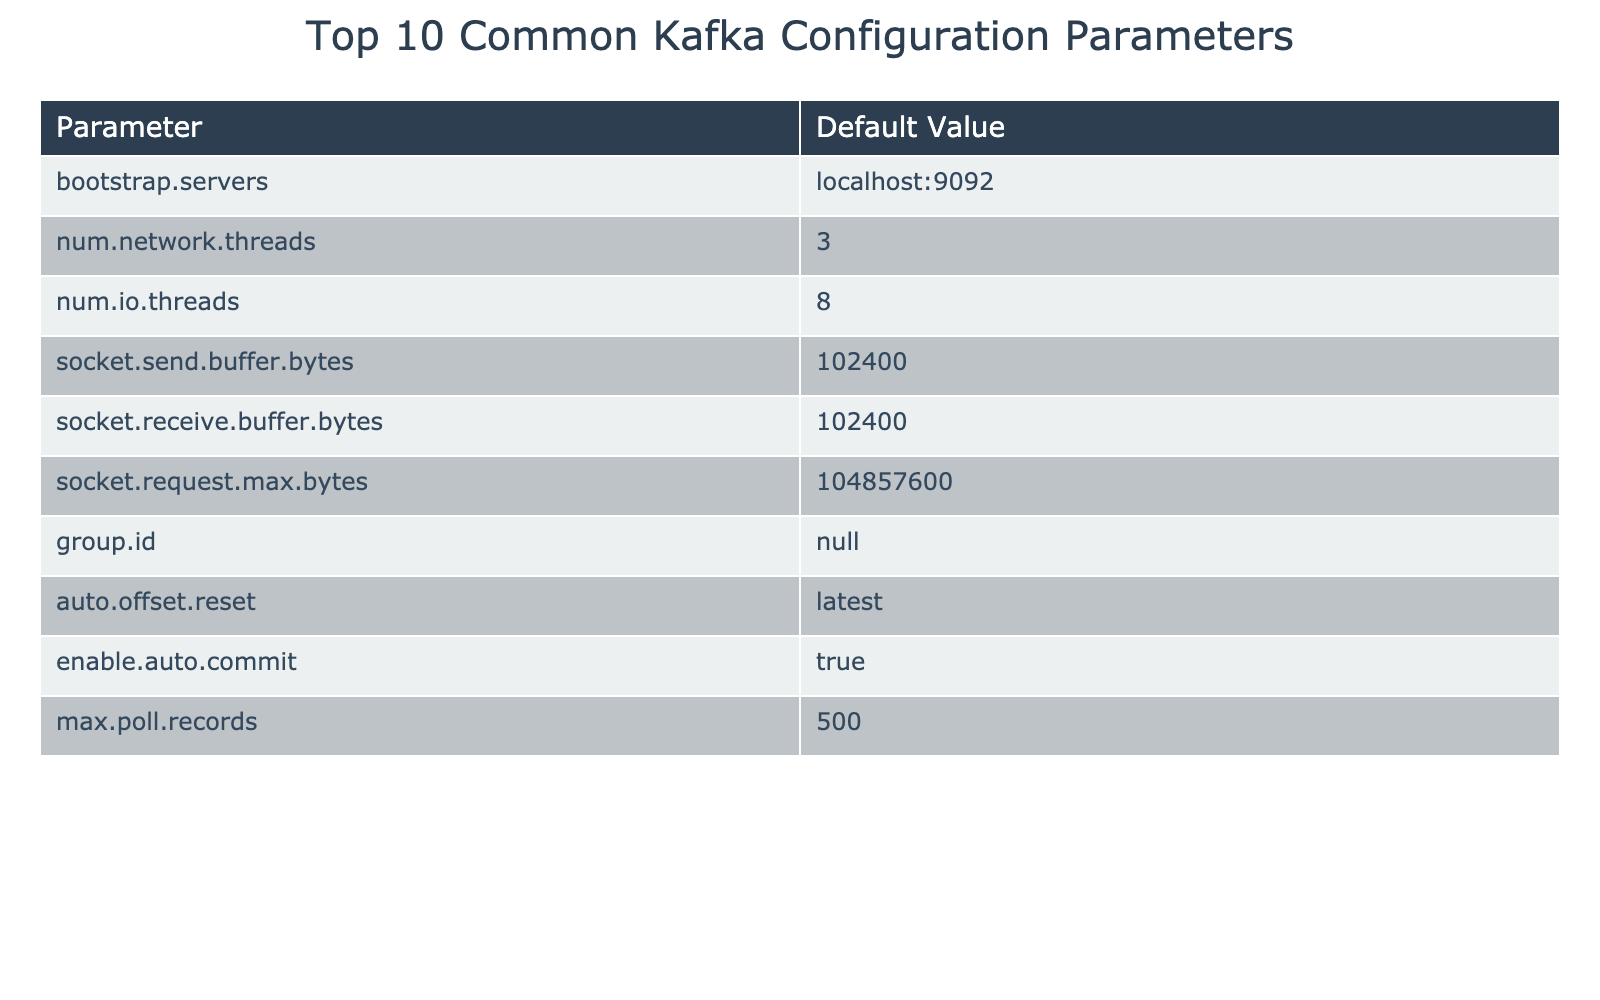What is the default value of `bootstrap.servers`? The table lists the default value for `bootstrap.servers` as `localhost:9092`.
Answer: localhost:9092 How many I/O threads are set by default? According to the table, the default for `num.io.threads` is 8, indicating that the system can handle 8 threads for I/O operations.
Answer: 8 Is `enable.auto.commit` set to true or false by default? The table shows that the default value for `enable.auto.commit` is `true`, meaning automatic offset commits are enabled.
Answer: true What is the default maximum number of records to poll? The table indicates that the default value for `max.poll.records` is 500, which is the maximum number of records returned in a single poll request.
Answer: 500 Are the defaults for `socket.send.buffer.bytes` and `socket.receive.buffer.bytes` the same? Both parameters are set to 102400 as per the table, indicating they have the same buffer size in bytes.
Answer: Yes What is the sum of `num.network.threads` and `num.io.threads`? The table shows `num.network.threads` is 3 and `num.io.threads` is 8. Adding these values gives 3 + 8 = 11.
Answer: 11 What is the default value of `group.id`? The table states that the default for `group.id` is an empty string, which signifies no specific group ID is set by default.
Answer: "" If the default `socket.request.max.bytes` is 104857600, how many megabytes is this? To convert bytes to megabytes, divide by 1048576 (1 MB = 1048576 bytes). Thus, 104857600 / 1048576 = 100 MB.
Answer: 100 MB If `auto.offset.reset` can be set to `latest` or `earliest`, what is its default value? The table indicates that the default for `auto.offset.reset` is `latest`, which means it will start reading from the most recent message by default.
Answer: latest Which configuration parameter has an empty default value? According to the table, the only parameter with an empty default value is `group.id`.
Answer: group.id 